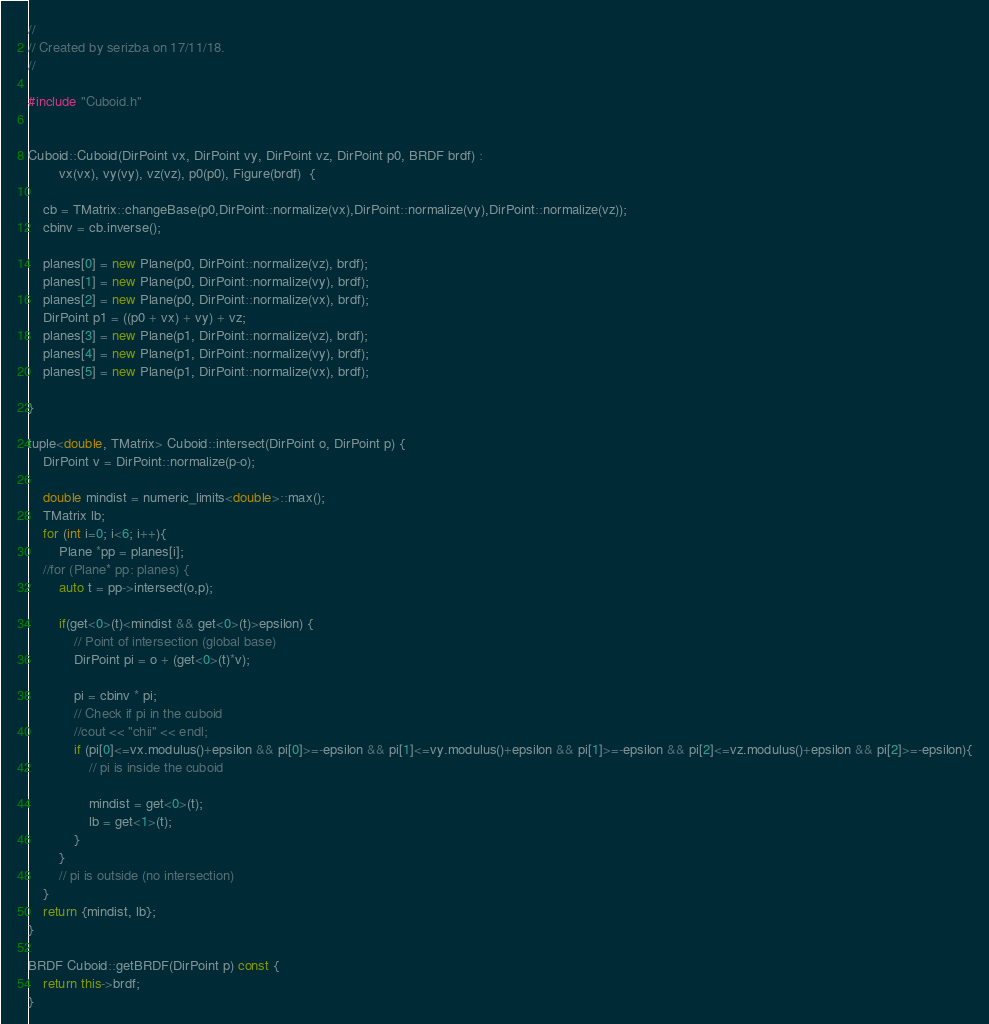<code> <loc_0><loc_0><loc_500><loc_500><_C++_>//
// Created by serizba on 17/11/18.
//

#include "Cuboid.h"


Cuboid::Cuboid(DirPoint vx, DirPoint vy, DirPoint vz, DirPoint p0, BRDF brdf) :
        vx(vx), vy(vy), vz(vz), p0(p0), Figure(brdf)  {

    cb = TMatrix::changeBase(p0,DirPoint::normalize(vx),DirPoint::normalize(vy),DirPoint::normalize(vz));
    cbinv = cb.inverse();

    planes[0] = new Plane(p0, DirPoint::normalize(vz), brdf);
    planes[1] = new Plane(p0, DirPoint::normalize(vy), brdf);
    planes[2] = new Plane(p0, DirPoint::normalize(vx), brdf);
    DirPoint p1 = ((p0 + vx) + vy) + vz;
    planes[3] = new Plane(p1, DirPoint::normalize(vz), brdf);
    planes[4] = new Plane(p1, DirPoint::normalize(vy), brdf);
    planes[5] = new Plane(p1, DirPoint::normalize(vx), brdf);

}

tuple<double, TMatrix> Cuboid::intersect(DirPoint o, DirPoint p) {
    DirPoint v = DirPoint::normalize(p-o);

    double mindist = numeric_limits<double>::max();
    TMatrix lb;
    for (int i=0; i<6; i++){
        Plane *pp = planes[i];
    //for (Plane* pp: planes) {
        auto t = pp->intersect(o,p);

        if(get<0>(t)<mindist && get<0>(t)>epsilon) {
            // Point of intersection (global base)
            DirPoint pi = o + (get<0>(t)*v);

            pi = cbinv * pi;
            // Check if pi in the cuboid
            //cout << "chii" << endl;
            if (pi[0]<=vx.modulus()+epsilon && pi[0]>=-epsilon && pi[1]<=vy.modulus()+epsilon && pi[1]>=-epsilon && pi[2]<=vz.modulus()+epsilon && pi[2]>=-epsilon){
                // pi is inside the cuboid

                mindist = get<0>(t);
                lb = get<1>(t);
            }
        }
        // pi is outside (no intersection)
    }
    return {mindist, lb};
}

BRDF Cuboid::getBRDF(DirPoint p) const {
    return this->brdf;
}

</code> 